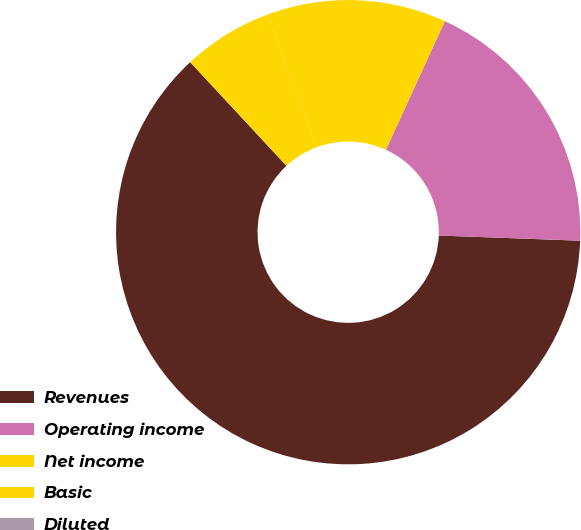Convert chart. <chart><loc_0><loc_0><loc_500><loc_500><pie_chart><fcel>Revenues<fcel>Operating income<fcel>Net income<fcel>Basic<fcel>Diluted<nl><fcel>62.5%<fcel>18.75%<fcel>12.5%<fcel>6.25%<fcel>0.0%<nl></chart> 